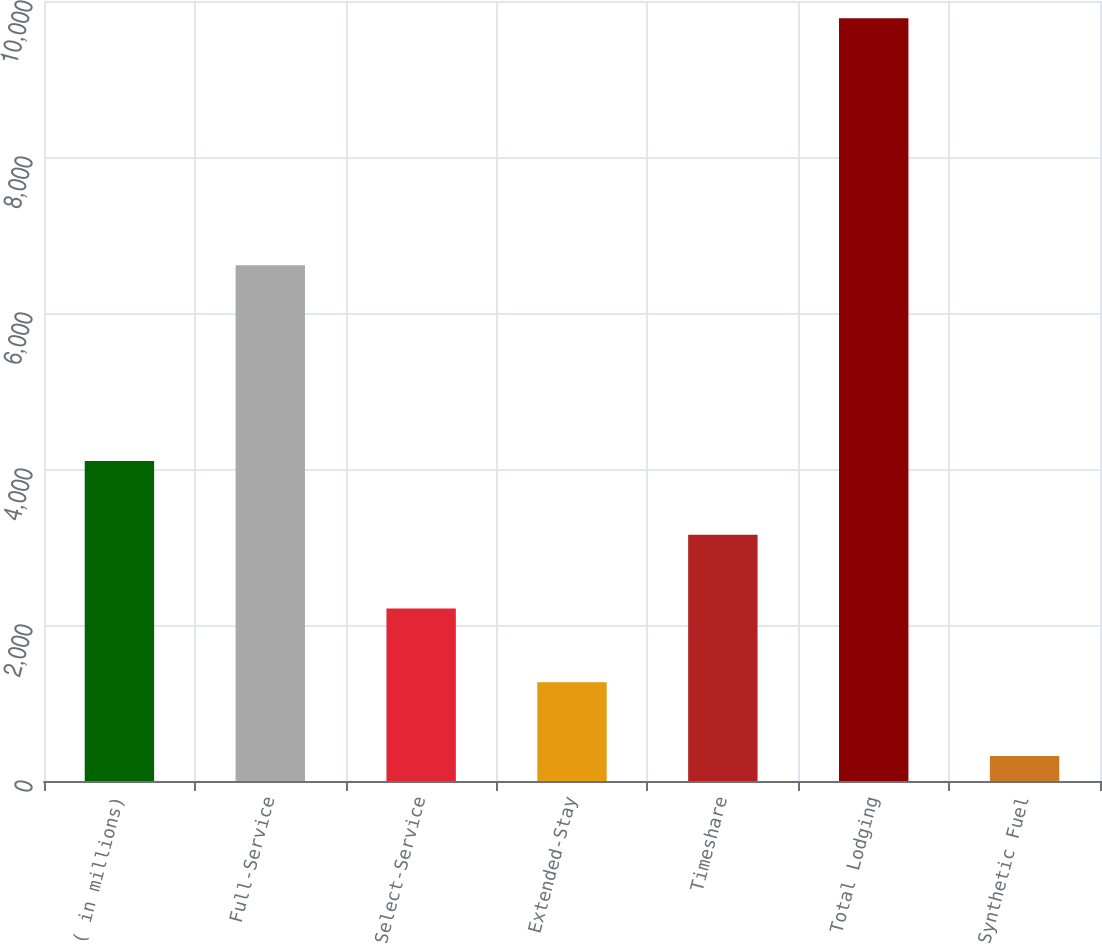<chart> <loc_0><loc_0><loc_500><loc_500><bar_chart><fcel>( in millions)<fcel>Full-Service<fcel>Select-Service<fcel>Extended-Stay<fcel>Timeshare<fcel>Total Lodging<fcel>Synthetic Fuel<nl><fcel>4103.8<fcel>6611<fcel>2212.4<fcel>1266.7<fcel>3158.1<fcel>9778<fcel>321<nl></chart> 